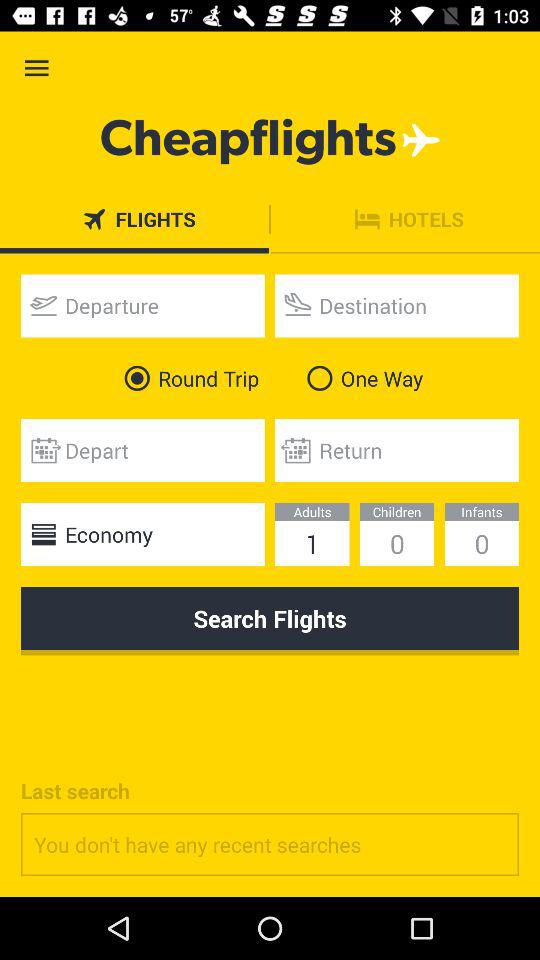What is the application name? The application name is "Cheapflights". 